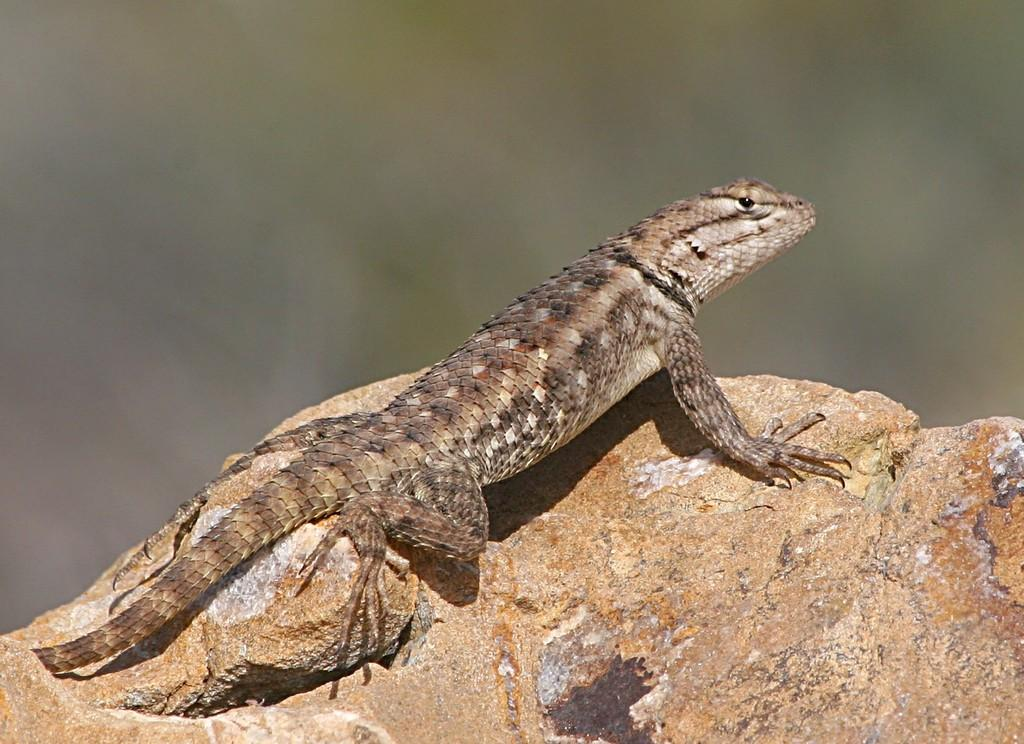What type of animal is in the image? There is a lizard in the image. Where is the lizard located? The lizard is on a rock. Can you describe the background of the image? The background of the image is blurred. What type of light is shining on the robin in the image? There is no robin present in the image; it features a lizard on a rock. 